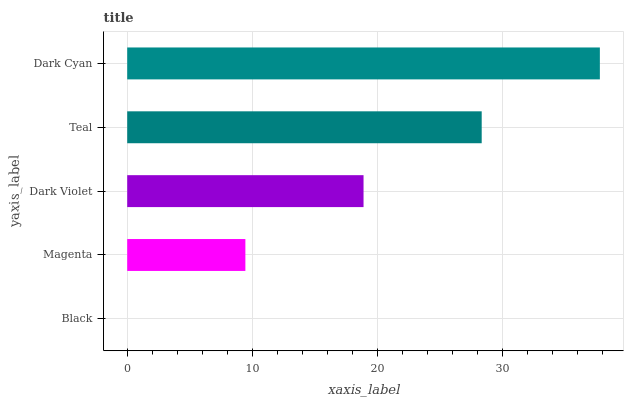Is Black the minimum?
Answer yes or no. Yes. Is Dark Cyan the maximum?
Answer yes or no. Yes. Is Magenta the minimum?
Answer yes or no. No. Is Magenta the maximum?
Answer yes or no. No. Is Magenta greater than Black?
Answer yes or no. Yes. Is Black less than Magenta?
Answer yes or no. Yes. Is Black greater than Magenta?
Answer yes or no. No. Is Magenta less than Black?
Answer yes or no. No. Is Dark Violet the high median?
Answer yes or no. Yes. Is Dark Violet the low median?
Answer yes or no. Yes. Is Teal the high median?
Answer yes or no. No. Is Dark Cyan the low median?
Answer yes or no. No. 